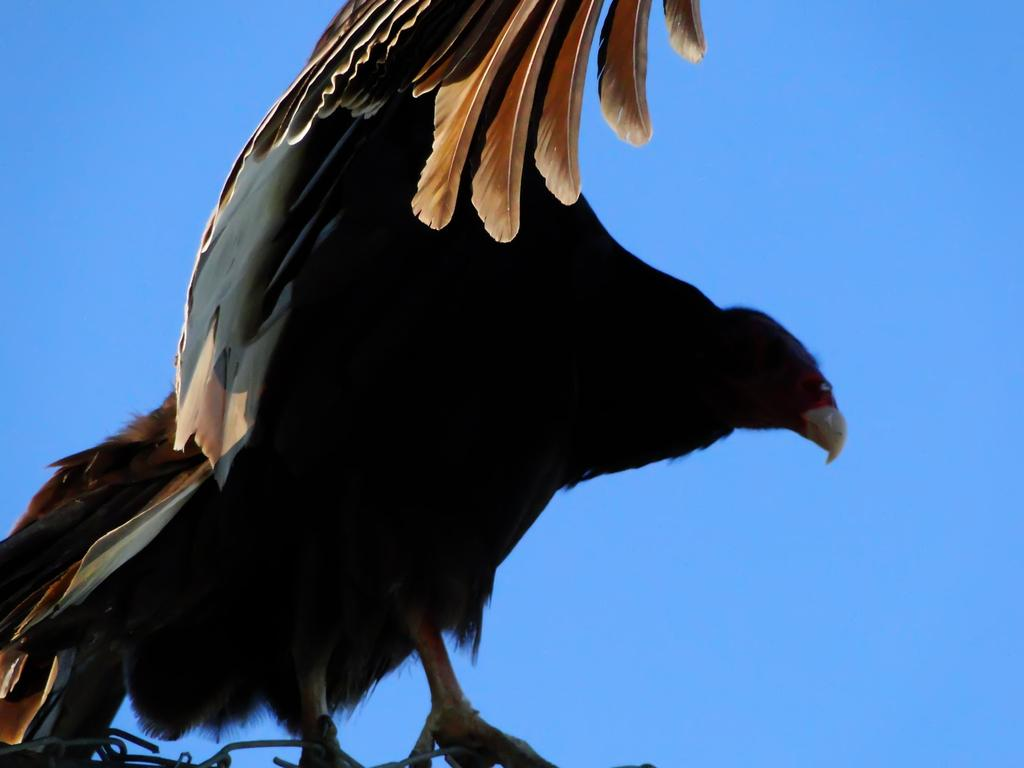What type of animal is in the image? There is a bird in the image. What color is the bird? The bird is black in color. What can be seen on the bird's body? The bird's feathers are visible. What is visible in the background of the image? The sky is visible in the background of the image. What color is the sky? The sky is blue in color. Where is the library located in the image? There is no library present in the image; it features a bird and the sky. What type of crib is visible in the image? There is no crib present in the image. 